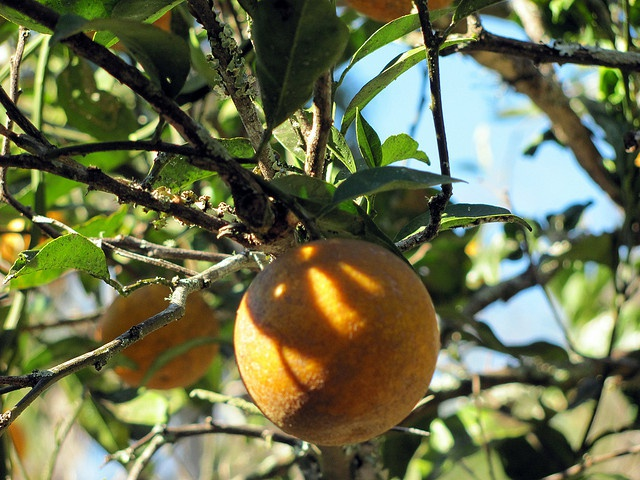Describe the objects in this image and their specific colors. I can see orange in black, maroon, and brown tones, orange in black, maroon, and olive tones, orange in black, maroon, darkgreen, and olive tones, orange in black, orange, khaki, and olive tones, and orange in black, olive, and maroon tones in this image. 